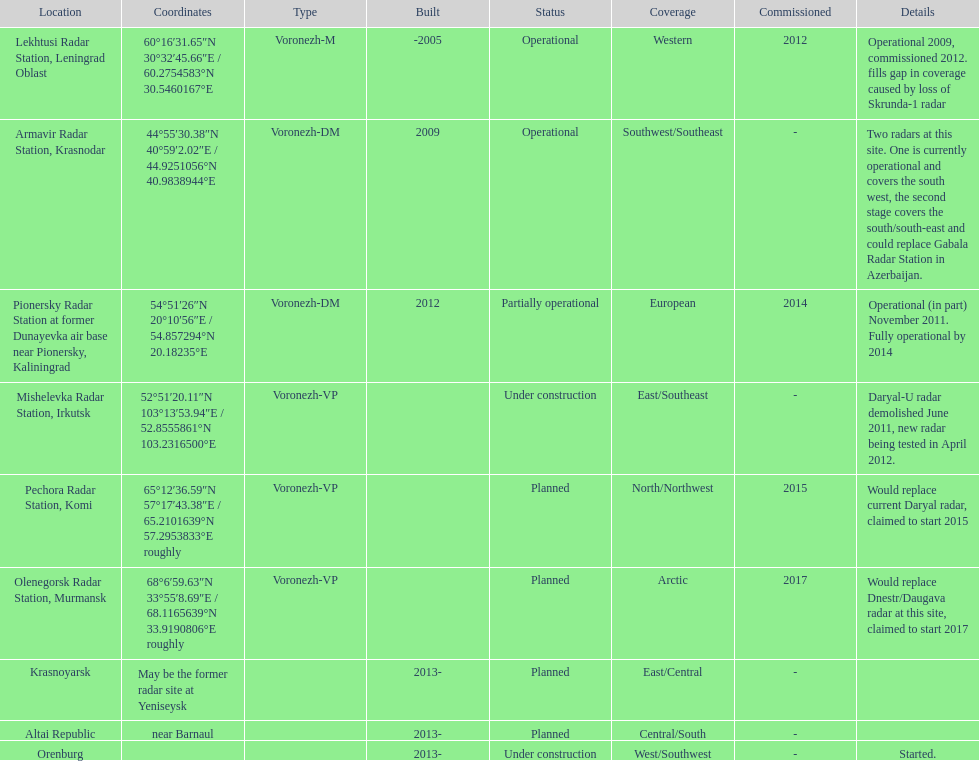How many voronezh radars were built before 2010? 2. 